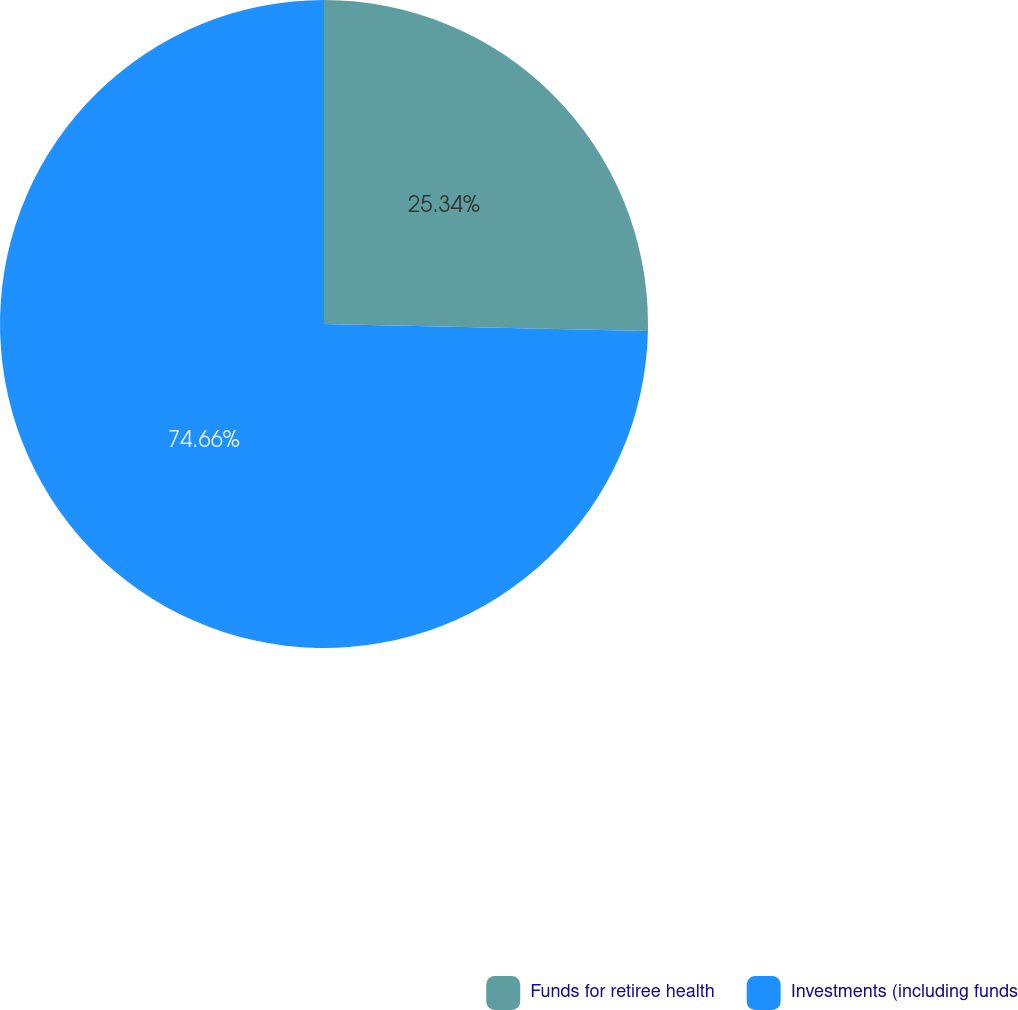Convert chart. <chart><loc_0><loc_0><loc_500><loc_500><pie_chart><fcel>Funds for retiree health<fcel>Investments (including funds<nl><fcel>25.34%<fcel>74.66%<nl></chart> 